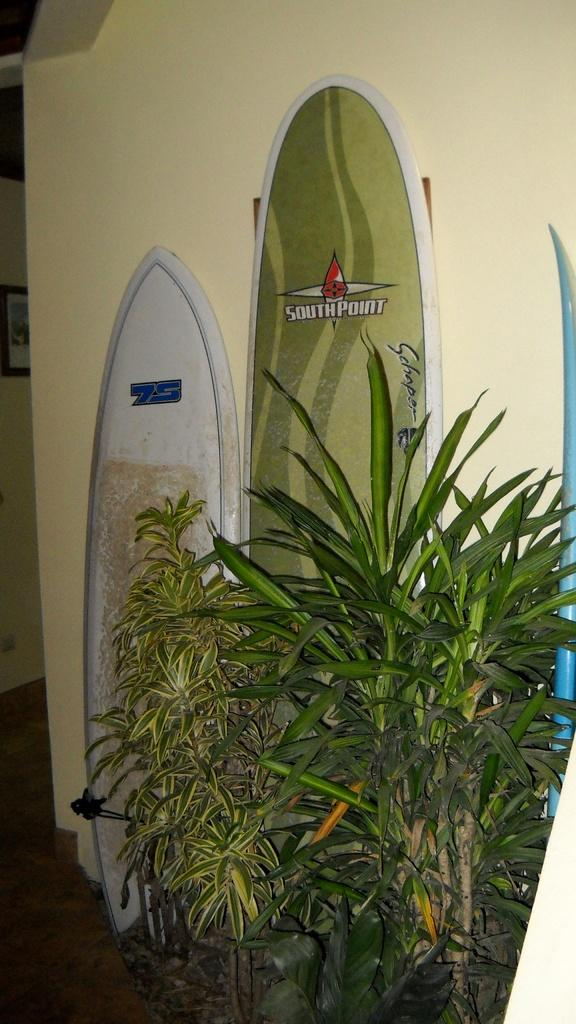What is located in the foreground of the picture? There are plants and skateboards in the foreground of the picture. What can be seen on the left side of the picture? There is a frame on the left side of the picture. What is located at the top of the picture? There is a well at the top of the picture. What type of mint is used to decorate the cake in the image? There is no mention of mint or cake in the provided facts, and therefore no such information can be derived from the image. 